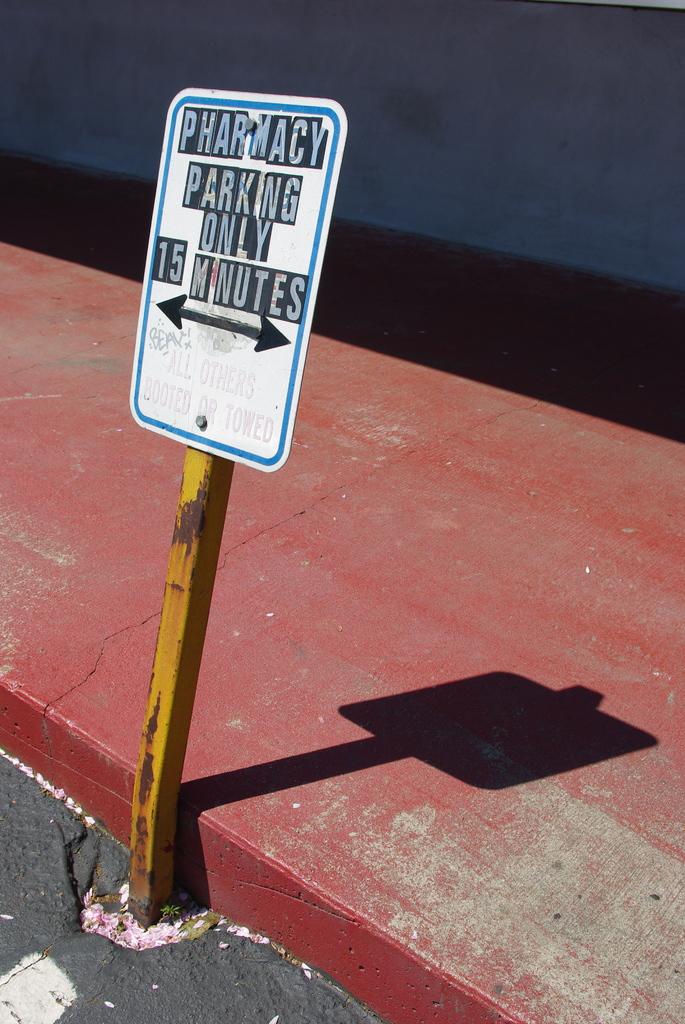How many minutes does this sign allow parking for?
Provide a short and direct response. 15. What does the parking sign say?
Your answer should be very brief. Pharmacy parking only 15 minutes. 